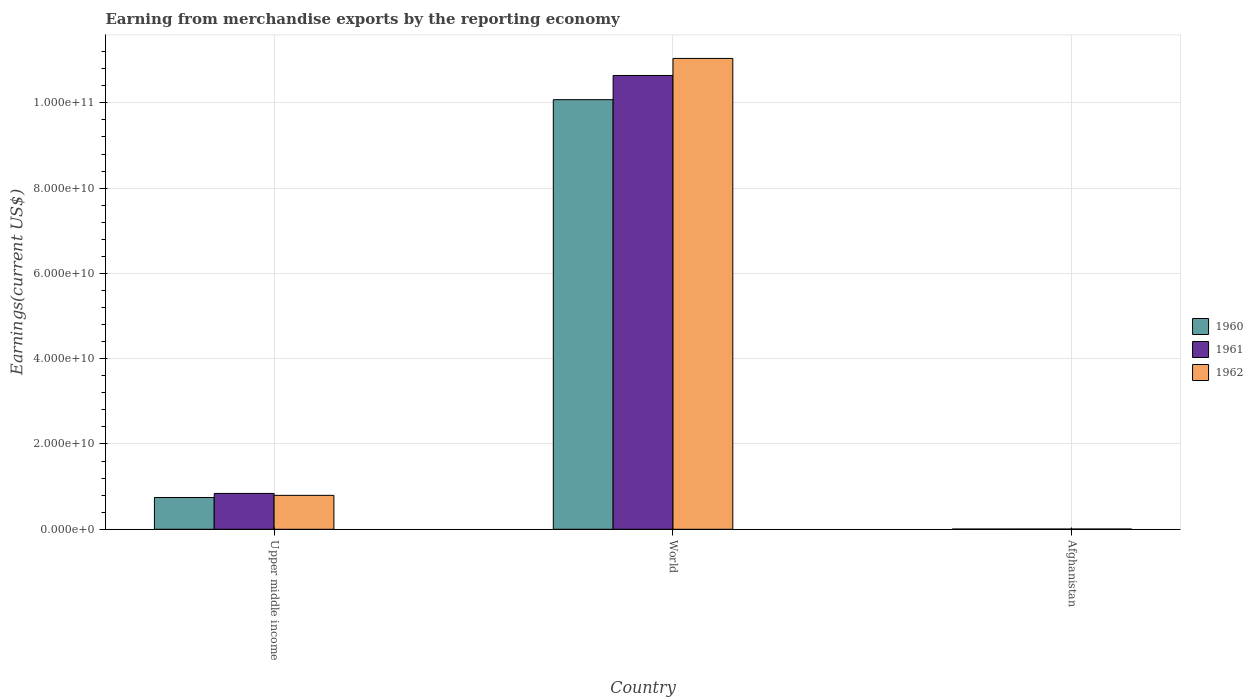How many different coloured bars are there?
Give a very brief answer. 3. Are the number of bars per tick equal to the number of legend labels?
Make the answer very short. Yes. How many bars are there on the 3rd tick from the left?
Keep it short and to the point. 3. What is the label of the 3rd group of bars from the left?
Provide a short and direct response. Afghanistan. In how many cases, is the number of bars for a given country not equal to the number of legend labels?
Offer a very short reply. 0. What is the amount earned from merchandise exports in 1960 in Upper middle income?
Your answer should be very brief. 7.45e+09. Across all countries, what is the maximum amount earned from merchandise exports in 1961?
Your response must be concise. 1.06e+11. Across all countries, what is the minimum amount earned from merchandise exports in 1961?
Give a very brief answer. 5.34e+07. In which country was the amount earned from merchandise exports in 1960 maximum?
Your response must be concise. World. In which country was the amount earned from merchandise exports in 1960 minimum?
Offer a terse response. Afghanistan. What is the total amount earned from merchandise exports in 1962 in the graph?
Offer a very short reply. 1.18e+11. What is the difference between the amount earned from merchandise exports in 1960 in Afghanistan and that in Upper middle income?
Ensure brevity in your answer.  -7.40e+09. What is the difference between the amount earned from merchandise exports in 1960 in Upper middle income and the amount earned from merchandise exports in 1962 in World?
Offer a very short reply. -1.03e+11. What is the average amount earned from merchandise exports in 1961 per country?
Your response must be concise. 3.83e+1. What is the difference between the amount earned from merchandise exports of/in 1961 and amount earned from merchandise exports of/in 1962 in Afghanistan?
Provide a succinct answer. -5.50e+06. What is the ratio of the amount earned from merchandise exports in 1962 in Afghanistan to that in Upper middle income?
Your answer should be very brief. 0.01. Is the amount earned from merchandise exports in 1962 in Afghanistan less than that in Upper middle income?
Your answer should be compact. Yes. Is the difference between the amount earned from merchandise exports in 1961 in Upper middle income and World greater than the difference between the amount earned from merchandise exports in 1962 in Upper middle income and World?
Make the answer very short. Yes. What is the difference between the highest and the second highest amount earned from merchandise exports in 1960?
Your answer should be very brief. 1.01e+11. What is the difference between the highest and the lowest amount earned from merchandise exports in 1961?
Your answer should be very brief. 1.06e+11. Is the sum of the amount earned from merchandise exports in 1960 in Afghanistan and Upper middle income greater than the maximum amount earned from merchandise exports in 1961 across all countries?
Offer a very short reply. No. What does the 2nd bar from the right in World represents?
Make the answer very short. 1961. Is it the case that in every country, the sum of the amount earned from merchandise exports in 1961 and amount earned from merchandise exports in 1962 is greater than the amount earned from merchandise exports in 1960?
Provide a succinct answer. Yes. How many countries are there in the graph?
Your answer should be compact. 3. Does the graph contain any zero values?
Offer a terse response. No. Does the graph contain grids?
Offer a very short reply. Yes. How many legend labels are there?
Keep it short and to the point. 3. What is the title of the graph?
Provide a succinct answer. Earning from merchandise exports by the reporting economy. What is the label or title of the X-axis?
Give a very brief answer. Country. What is the label or title of the Y-axis?
Keep it short and to the point. Earnings(current US$). What is the Earnings(current US$) of 1960 in Upper middle income?
Keep it short and to the point. 7.45e+09. What is the Earnings(current US$) in 1961 in Upper middle income?
Provide a short and direct response. 8.41e+09. What is the Earnings(current US$) of 1962 in Upper middle income?
Offer a terse response. 7.96e+09. What is the Earnings(current US$) of 1960 in World?
Give a very brief answer. 1.01e+11. What is the Earnings(current US$) of 1961 in World?
Provide a succinct answer. 1.06e+11. What is the Earnings(current US$) of 1962 in World?
Keep it short and to the point. 1.10e+11. What is the Earnings(current US$) in 1960 in Afghanistan?
Make the answer very short. 4.99e+07. What is the Earnings(current US$) of 1961 in Afghanistan?
Make the answer very short. 5.34e+07. What is the Earnings(current US$) of 1962 in Afghanistan?
Keep it short and to the point. 5.89e+07. Across all countries, what is the maximum Earnings(current US$) of 1960?
Provide a short and direct response. 1.01e+11. Across all countries, what is the maximum Earnings(current US$) in 1961?
Provide a succinct answer. 1.06e+11. Across all countries, what is the maximum Earnings(current US$) in 1962?
Offer a terse response. 1.10e+11. Across all countries, what is the minimum Earnings(current US$) in 1960?
Give a very brief answer. 4.99e+07. Across all countries, what is the minimum Earnings(current US$) in 1961?
Provide a short and direct response. 5.34e+07. Across all countries, what is the minimum Earnings(current US$) of 1962?
Provide a short and direct response. 5.89e+07. What is the total Earnings(current US$) of 1960 in the graph?
Offer a terse response. 1.08e+11. What is the total Earnings(current US$) of 1961 in the graph?
Your answer should be compact. 1.15e+11. What is the total Earnings(current US$) of 1962 in the graph?
Provide a short and direct response. 1.18e+11. What is the difference between the Earnings(current US$) in 1960 in Upper middle income and that in World?
Your answer should be compact. -9.33e+1. What is the difference between the Earnings(current US$) of 1961 in Upper middle income and that in World?
Your answer should be compact. -9.80e+1. What is the difference between the Earnings(current US$) in 1962 in Upper middle income and that in World?
Offer a very short reply. -1.02e+11. What is the difference between the Earnings(current US$) of 1960 in Upper middle income and that in Afghanistan?
Provide a succinct answer. 7.40e+09. What is the difference between the Earnings(current US$) of 1961 in Upper middle income and that in Afghanistan?
Offer a very short reply. 8.35e+09. What is the difference between the Earnings(current US$) in 1962 in Upper middle income and that in Afghanistan?
Provide a short and direct response. 7.90e+09. What is the difference between the Earnings(current US$) in 1960 in World and that in Afghanistan?
Your answer should be very brief. 1.01e+11. What is the difference between the Earnings(current US$) of 1961 in World and that in Afghanistan?
Offer a terse response. 1.06e+11. What is the difference between the Earnings(current US$) in 1962 in World and that in Afghanistan?
Your answer should be very brief. 1.10e+11. What is the difference between the Earnings(current US$) in 1960 in Upper middle income and the Earnings(current US$) in 1961 in World?
Offer a very short reply. -9.90e+1. What is the difference between the Earnings(current US$) in 1960 in Upper middle income and the Earnings(current US$) in 1962 in World?
Provide a short and direct response. -1.03e+11. What is the difference between the Earnings(current US$) in 1961 in Upper middle income and the Earnings(current US$) in 1962 in World?
Ensure brevity in your answer.  -1.02e+11. What is the difference between the Earnings(current US$) in 1960 in Upper middle income and the Earnings(current US$) in 1961 in Afghanistan?
Your response must be concise. 7.40e+09. What is the difference between the Earnings(current US$) of 1960 in Upper middle income and the Earnings(current US$) of 1962 in Afghanistan?
Offer a very short reply. 7.39e+09. What is the difference between the Earnings(current US$) of 1961 in Upper middle income and the Earnings(current US$) of 1962 in Afghanistan?
Give a very brief answer. 8.35e+09. What is the difference between the Earnings(current US$) in 1960 in World and the Earnings(current US$) in 1961 in Afghanistan?
Your answer should be compact. 1.01e+11. What is the difference between the Earnings(current US$) of 1960 in World and the Earnings(current US$) of 1962 in Afghanistan?
Give a very brief answer. 1.01e+11. What is the difference between the Earnings(current US$) in 1961 in World and the Earnings(current US$) in 1962 in Afghanistan?
Your answer should be compact. 1.06e+11. What is the average Earnings(current US$) of 1960 per country?
Keep it short and to the point. 3.61e+1. What is the average Earnings(current US$) of 1961 per country?
Your answer should be compact. 3.83e+1. What is the average Earnings(current US$) in 1962 per country?
Your answer should be compact. 3.95e+1. What is the difference between the Earnings(current US$) of 1960 and Earnings(current US$) of 1961 in Upper middle income?
Offer a terse response. -9.55e+08. What is the difference between the Earnings(current US$) of 1960 and Earnings(current US$) of 1962 in Upper middle income?
Keep it short and to the point. -5.05e+08. What is the difference between the Earnings(current US$) in 1961 and Earnings(current US$) in 1962 in Upper middle income?
Keep it short and to the point. 4.50e+08. What is the difference between the Earnings(current US$) in 1960 and Earnings(current US$) in 1961 in World?
Your answer should be very brief. -5.67e+09. What is the difference between the Earnings(current US$) in 1960 and Earnings(current US$) in 1962 in World?
Your answer should be very brief. -9.68e+09. What is the difference between the Earnings(current US$) in 1961 and Earnings(current US$) in 1962 in World?
Ensure brevity in your answer.  -4.00e+09. What is the difference between the Earnings(current US$) in 1960 and Earnings(current US$) in 1961 in Afghanistan?
Ensure brevity in your answer.  -3.50e+06. What is the difference between the Earnings(current US$) of 1960 and Earnings(current US$) of 1962 in Afghanistan?
Your answer should be compact. -9.00e+06. What is the difference between the Earnings(current US$) of 1961 and Earnings(current US$) of 1962 in Afghanistan?
Your response must be concise. -5.50e+06. What is the ratio of the Earnings(current US$) of 1960 in Upper middle income to that in World?
Give a very brief answer. 0.07. What is the ratio of the Earnings(current US$) of 1961 in Upper middle income to that in World?
Your response must be concise. 0.08. What is the ratio of the Earnings(current US$) of 1962 in Upper middle income to that in World?
Offer a terse response. 0.07. What is the ratio of the Earnings(current US$) of 1960 in Upper middle income to that in Afghanistan?
Your answer should be very brief. 149.34. What is the ratio of the Earnings(current US$) of 1961 in Upper middle income to that in Afghanistan?
Provide a succinct answer. 157.43. What is the ratio of the Earnings(current US$) in 1962 in Upper middle income to that in Afghanistan?
Keep it short and to the point. 135.08. What is the ratio of the Earnings(current US$) in 1960 in World to that in Afghanistan?
Ensure brevity in your answer.  2019.04. What is the ratio of the Earnings(current US$) in 1961 in World to that in Afghanistan?
Ensure brevity in your answer.  1992.96. What is the ratio of the Earnings(current US$) in 1962 in World to that in Afghanistan?
Your answer should be very brief. 1874.8. What is the difference between the highest and the second highest Earnings(current US$) of 1960?
Offer a very short reply. 9.33e+1. What is the difference between the highest and the second highest Earnings(current US$) of 1961?
Ensure brevity in your answer.  9.80e+1. What is the difference between the highest and the second highest Earnings(current US$) in 1962?
Your answer should be very brief. 1.02e+11. What is the difference between the highest and the lowest Earnings(current US$) of 1960?
Provide a succinct answer. 1.01e+11. What is the difference between the highest and the lowest Earnings(current US$) of 1961?
Offer a very short reply. 1.06e+11. What is the difference between the highest and the lowest Earnings(current US$) of 1962?
Provide a succinct answer. 1.10e+11. 